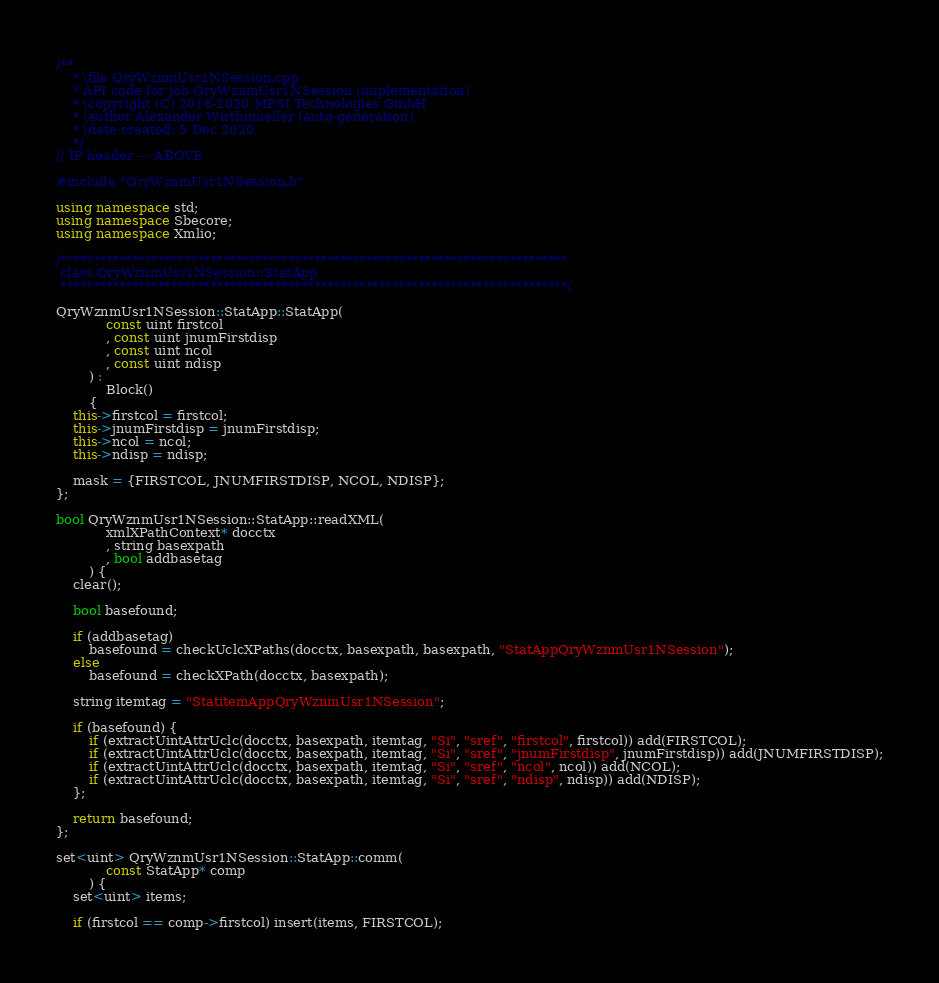Convert code to text. <code><loc_0><loc_0><loc_500><loc_500><_C++_>/**
	* \file QryWznmUsr1NSession.cpp
	* API code for job QryWznmUsr1NSession (implementation)
	* \copyright (C) 2016-2020 MPSI Technologies GmbH
	* \author Alexander Wirthmueller (auto-generation)
	* \date created: 5 Dec 2020
	*/
// IP header --- ABOVE

#include "QryWznmUsr1NSession.h"

using namespace std;
using namespace Sbecore;
using namespace Xmlio;

/******************************************************************************
 class QryWznmUsr1NSession::StatApp
 ******************************************************************************/

QryWznmUsr1NSession::StatApp::StatApp(
			const uint firstcol
			, const uint jnumFirstdisp
			, const uint ncol
			, const uint ndisp
		) :
			Block()
		{
	this->firstcol = firstcol;
	this->jnumFirstdisp = jnumFirstdisp;
	this->ncol = ncol;
	this->ndisp = ndisp;

	mask = {FIRSTCOL, JNUMFIRSTDISP, NCOL, NDISP};
};

bool QryWznmUsr1NSession::StatApp::readXML(
			xmlXPathContext* docctx
			, string basexpath
			, bool addbasetag
		) {
	clear();

	bool basefound;

	if (addbasetag)
		basefound = checkUclcXPaths(docctx, basexpath, basexpath, "StatAppQryWznmUsr1NSession");
	else
		basefound = checkXPath(docctx, basexpath);

	string itemtag = "StatitemAppQryWznmUsr1NSession";

	if (basefound) {
		if (extractUintAttrUclc(docctx, basexpath, itemtag, "Si", "sref", "firstcol", firstcol)) add(FIRSTCOL);
		if (extractUintAttrUclc(docctx, basexpath, itemtag, "Si", "sref", "jnumFirstdisp", jnumFirstdisp)) add(JNUMFIRSTDISP);
		if (extractUintAttrUclc(docctx, basexpath, itemtag, "Si", "sref", "ncol", ncol)) add(NCOL);
		if (extractUintAttrUclc(docctx, basexpath, itemtag, "Si", "sref", "ndisp", ndisp)) add(NDISP);
	};

	return basefound;
};

set<uint> QryWznmUsr1NSession::StatApp::comm(
			const StatApp* comp
		) {
	set<uint> items;

	if (firstcol == comp->firstcol) insert(items, FIRSTCOL);</code> 